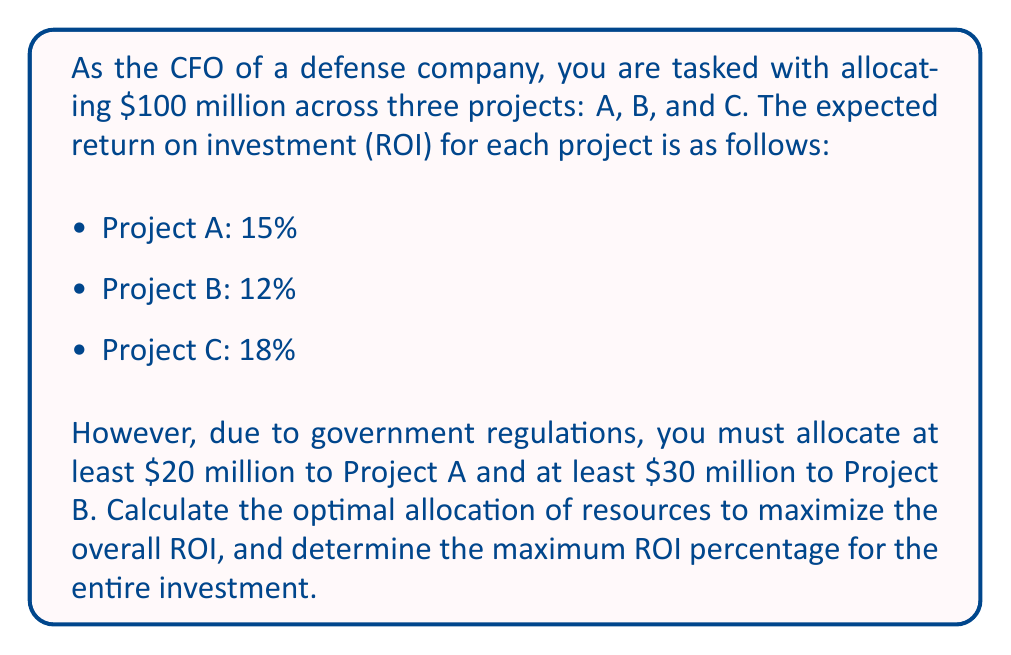Can you answer this question? To solve this problem, we'll follow these steps:

1. Set up variables:
Let $x_A$, $x_B$, and $x_C$ be the amounts allocated to Projects A, B, and C, respectively.

2. Define constraints:
$$x_A + x_B + x_C = 100$$ (total budget)
$$x_A \geq 20$$ (minimum for Project A)
$$x_B \geq 30$$ (minimum for Project B)
$$x_C \geq 0$$ (non-negative allocation for Project C)

3. Set up the objective function:
Maximize ROI = $\frac{0.15x_A + 0.12x_B + 0.18x_C}{100}$

4. Solve the optimization problem:
To maximize ROI, we should allocate the minimum required amounts to Projects A and B, and the remaining amount to Project C, which has the highest ROI.

$x_A = 20$
$x_B = 30$
$x_C = 100 - 20 - 30 = 50$

5. Calculate the maximum ROI:
$$\text{Maximum ROI} = \frac{0.15(20) + 0.12(30) + 0.18(50)}{100}$$
$$= \frac{3 + 3.6 + 9}{100} = \frac{15.6}{100} = 0.156 = 15.6\%$$
Answer: The optimal allocation is:
Project A: $20 million
Project B: $30 million
Project C: $50 million

The maximum ROI for the entire investment is 15.6%. 